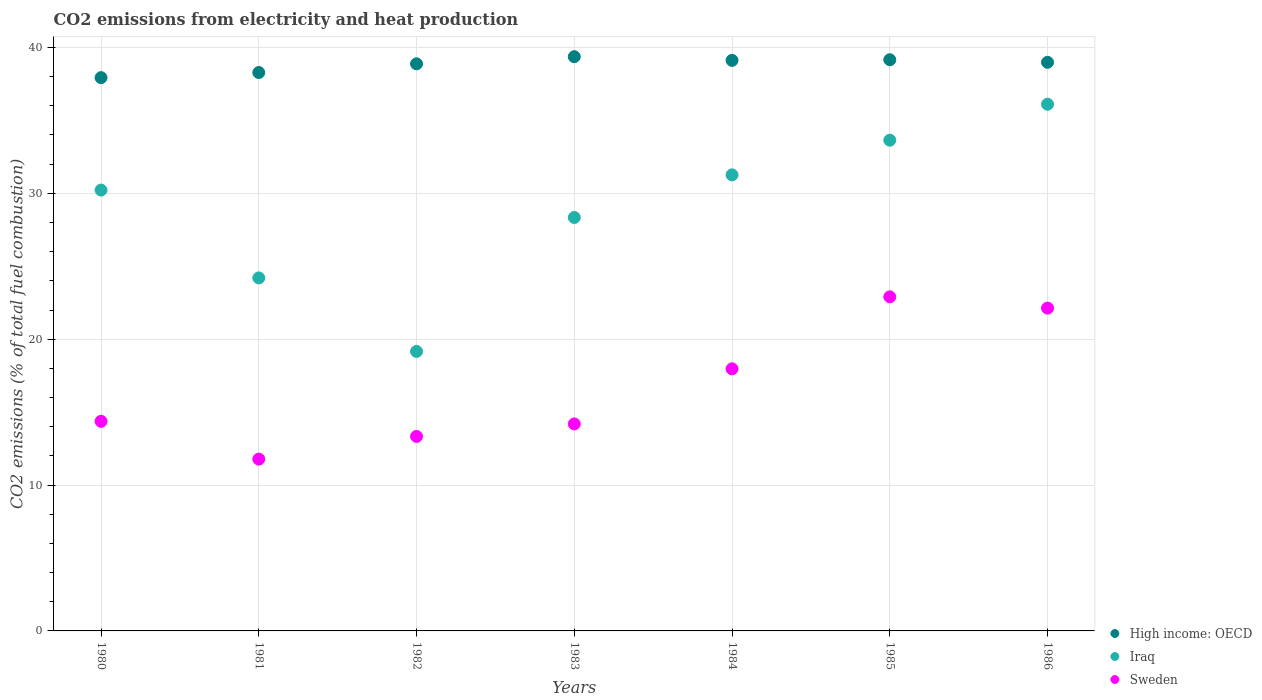Is the number of dotlines equal to the number of legend labels?
Make the answer very short. Yes. What is the amount of CO2 emitted in Sweden in 1981?
Provide a succinct answer. 11.78. Across all years, what is the maximum amount of CO2 emitted in Iraq?
Your answer should be compact. 36.11. Across all years, what is the minimum amount of CO2 emitted in High income: OECD?
Provide a short and direct response. 37.93. In which year was the amount of CO2 emitted in Sweden maximum?
Your answer should be very brief. 1985. In which year was the amount of CO2 emitted in Sweden minimum?
Your answer should be compact. 1981. What is the total amount of CO2 emitted in High income: OECD in the graph?
Offer a terse response. 271.71. What is the difference between the amount of CO2 emitted in High income: OECD in 1981 and that in 1986?
Provide a short and direct response. -0.7. What is the difference between the amount of CO2 emitted in High income: OECD in 1983 and the amount of CO2 emitted in Sweden in 1981?
Keep it short and to the point. 27.59. What is the average amount of CO2 emitted in High income: OECD per year?
Make the answer very short. 38.82. In the year 1985, what is the difference between the amount of CO2 emitted in Sweden and amount of CO2 emitted in High income: OECD?
Offer a terse response. -16.25. What is the ratio of the amount of CO2 emitted in Sweden in 1982 to that in 1985?
Provide a succinct answer. 0.58. Is the amount of CO2 emitted in Iraq in 1983 less than that in 1986?
Give a very brief answer. Yes. What is the difference between the highest and the second highest amount of CO2 emitted in High income: OECD?
Ensure brevity in your answer.  0.21. What is the difference between the highest and the lowest amount of CO2 emitted in Sweden?
Ensure brevity in your answer.  11.12. In how many years, is the amount of CO2 emitted in Iraq greater than the average amount of CO2 emitted in Iraq taken over all years?
Provide a short and direct response. 4. Is the sum of the amount of CO2 emitted in Sweden in 1980 and 1982 greater than the maximum amount of CO2 emitted in Iraq across all years?
Ensure brevity in your answer.  No. Is the amount of CO2 emitted in Iraq strictly greater than the amount of CO2 emitted in Sweden over the years?
Provide a short and direct response. Yes. Is the amount of CO2 emitted in High income: OECD strictly less than the amount of CO2 emitted in Iraq over the years?
Ensure brevity in your answer.  No. How many years are there in the graph?
Keep it short and to the point. 7. What is the title of the graph?
Keep it short and to the point. CO2 emissions from electricity and heat production. Does "Suriname" appear as one of the legend labels in the graph?
Keep it short and to the point. No. What is the label or title of the Y-axis?
Your answer should be very brief. CO2 emissions (% of total fuel combustion). What is the CO2 emissions (% of total fuel combustion) of High income: OECD in 1980?
Keep it short and to the point. 37.93. What is the CO2 emissions (% of total fuel combustion) in Iraq in 1980?
Your answer should be very brief. 30.22. What is the CO2 emissions (% of total fuel combustion) of Sweden in 1980?
Your response must be concise. 14.37. What is the CO2 emissions (% of total fuel combustion) in High income: OECD in 1981?
Make the answer very short. 38.28. What is the CO2 emissions (% of total fuel combustion) of Iraq in 1981?
Your response must be concise. 24.2. What is the CO2 emissions (% of total fuel combustion) in Sweden in 1981?
Make the answer very short. 11.78. What is the CO2 emissions (% of total fuel combustion) of High income: OECD in 1982?
Your response must be concise. 38.88. What is the CO2 emissions (% of total fuel combustion) in Iraq in 1982?
Your answer should be very brief. 19.16. What is the CO2 emissions (% of total fuel combustion) in Sweden in 1982?
Your answer should be compact. 13.33. What is the CO2 emissions (% of total fuel combustion) of High income: OECD in 1983?
Your answer should be compact. 39.37. What is the CO2 emissions (% of total fuel combustion) of Iraq in 1983?
Your answer should be compact. 28.34. What is the CO2 emissions (% of total fuel combustion) in Sweden in 1983?
Your answer should be compact. 14.19. What is the CO2 emissions (% of total fuel combustion) in High income: OECD in 1984?
Your answer should be very brief. 39.11. What is the CO2 emissions (% of total fuel combustion) in Iraq in 1984?
Provide a succinct answer. 31.26. What is the CO2 emissions (% of total fuel combustion) of Sweden in 1984?
Your response must be concise. 17.97. What is the CO2 emissions (% of total fuel combustion) of High income: OECD in 1985?
Your answer should be compact. 39.16. What is the CO2 emissions (% of total fuel combustion) of Iraq in 1985?
Give a very brief answer. 33.64. What is the CO2 emissions (% of total fuel combustion) in Sweden in 1985?
Offer a terse response. 22.9. What is the CO2 emissions (% of total fuel combustion) in High income: OECD in 1986?
Make the answer very short. 38.98. What is the CO2 emissions (% of total fuel combustion) of Iraq in 1986?
Offer a very short reply. 36.11. What is the CO2 emissions (% of total fuel combustion) of Sweden in 1986?
Offer a very short reply. 22.13. Across all years, what is the maximum CO2 emissions (% of total fuel combustion) of High income: OECD?
Give a very brief answer. 39.37. Across all years, what is the maximum CO2 emissions (% of total fuel combustion) in Iraq?
Offer a terse response. 36.11. Across all years, what is the maximum CO2 emissions (% of total fuel combustion) of Sweden?
Offer a very short reply. 22.9. Across all years, what is the minimum CO2 emissions (% of total fuel combustion) of High income: OECD?
Provide a short and direct response. 37.93. Across all years, what is the minimum CO2 emissions (% of total fuel combustion) in Iraq?
Your answer should be very brief. 19.16. Across all years, what is the minimum CO2 emissions (% of total fuel combustion) in Sweden?
Give a very brief answer. 11.78. What is the total CO2 emissions (% of total fuel combustion) in High income: OECD in the graph?
Keep it short and to the point. 271.71. What is the total CO2 emissions (% of total fuel combustion) in Iraq in the graph?
Give a very brief answer. 202.94. What is the total CO2 emissions (% of total fuel combustion) in Sweden in the graph?
Offer a terse response. 116.67. What is the difference between the CO2 emissions (% of total fuel combustion) in High income: OECD in 1980 and that in 1981?
Your answer should be compact. -0.35. What is the difference between the CO2 emissions (% of total fuel combustion) of Iraq in 1980 and that in 1981?
Your answer should be very brief. 6.02. What is the difference between the CO2 emissions (% of total fuel combustion) of Sweden in 1980 and that in 1981?
Offer a terse response. 2.59. What is the difference between the CO2 emissions (% of total fuel combustion) of High income: OECD in 1980 and that in 1982?
Provide a succinct answer. -0.95. What is the difference between the CO2 emissions (% of total fuel combustion) of Iraq in 1980 and that in 1982?
Offer a very short reply. 11.06. What is the difference between the CO2 emissions (% of total fuel combustion) in Sweden in 1980 and that in 1982?
Offer a very short reply. 1.03. What is the difference between the CO2 emissions (% of total fuel combustion) in High income: OECD in 1980 and that in 1983?
Offer a terse response. -1.44. What is the difference between the CO2 emissions (% of total fuel combustion) in Iraq in 1980 and that in 1983?
Provide a short and direct response. 1.88. What is the difference between the CO2 emissions (% of total fuel combustion) in Sweden in 1980 and that in 1983?
Offer a terse response. 0.18. What is the difference between the CO2 emissions (% of total fuel combustion) in High income: OECD in 1980 and that in 1984?
Ensure brevity in your answer.  -1.18. What is the difference between the CO2 emissions (% of total fuel combustion) in Iraq in 1980 and that in 1984?
Make the answer very short. -1.04. What is the difference between the CO2 emissions (% of total fuel combustion) in Sweden in 1980 and that in 1984?
Make the answer very short. -3.6. What is the difference between the CO2 emissions (% of total fuel combustion) of High income: OECD in 1980 and that in 1985?
Your response must be concise. -1.23. What is the difference between the CO2 emissions (% of total fuel combustion) in Iraq in 1980 and that in 1985?
Make the answer very short. -3.42. What is the difference between the CO2 emissions (% of total fuel combustion) of Sweden in 1980 and that in 1985?
Offer a terse response. -8.53. What is the difference between the CO2 emissions (% of total fuel combustion) in High income: OECD in 1980 and that in 1986?
Offer a terse response. -1.05. What is the difference between the CO2 emissions (% of total fuel combustion) of Iraq in 1980 and that in 1986?
Keep it short and to the point. -5.88. What is the difference between the CO2 emissions (% of total fuel combustion) of Sweden in 1980 and that in 1986?
Provide a succinct answer. -7.76. What is the difference between the CO2 emissions (% of total fuel combustion) of High income: OECD in 1981 and that in 1982?
Keep it short and to the point. -0.6. What is the difference between the CO2 emissions (% of total fuel combustion) of Iraq in 1981 and that in 1982?
Provide a short and direct response. 5.04. What is the difference between the CO2 emissions (% of total fuel combustion) of Sweden in 1981 and that in 1982?
Provide a short and direct response. -1.56. What is the difference between the CO2 emissions (% of total fuel combustion) in High income: OECD in 1981 and that in 1983?
Provide a succinct answer. -1.08. What is the difference between the CO2 emissions (% of total fuel combustion) in Iraq in 1981 and that in 1983?
Ensure brevity in your answer.  -4.14. What is the difference between the CO2 emissions (% of total fuel combustion) of Sweden in 1981 and that in 1983?
Give a very brief answer. -2.41. What is the difference between the CO2 emissions (% of total fuel combustion) of High income: OECD in 1981 and that in 1984?
Give a very brief answer. -0.83. What is the difference between the CO2 emissions (% of total fuel combustion) in Iraq in 1981 and that in 1984?
Provide a succinct answer. -7.06. What is the difference between the CO2 emissions (% of total fuel combustion) of Sweden in 1981 and that in 1984?
Ensure brevity in your answer.  -6.19. What is the difference between the CO2 emissions (% of total fuel combustion) of High income: OECD in 1981 and that in 1985?
Keep it short and to the point. -0.88. What is the difference between the CO2 emissions (% of total fuel combustion) of Iraq in 1981 and that in 1985?
Provide a short and direct response. -9.44. What is the difference between the CO2 emissions (% of total fuel combustion) in Sweden in 1981 and that in 1985?
Offer a terse response. -11.12. What is the difference between the CO2 emissions (% of total fuel combustion) in High income: OECD in 1981 and that in 1986?
Ensure brevity in your answer.  -0.7. What is the difference between the CO2 emissions (% of total fuel combustion) of Iraq in 1981 and that in 1986?
Offer a terse response. -11.91. What is the difference between the CO2 emissions (% of total fuel combustion) in Sweden in 1981 and that in 1986?
Provide a short and direct response. -10.35. What is the difference between the CO2 emissions (% of total fuel combustion) of High income: OECD in 1982 and that in 1983?
Your answer should be compact. -0.49. What is the difference between the CO2 emissions (% of total fuel combustion) of Iraq in 1982 and that in 1983?
Make the answer very short. -9.18. What is the difference between the CO2 emissions (% of total fuel combustion) of Sweden in 1982 and that in 1983?
Offer a terse response. -0.86. What is the difference between the CO2 emissions (% of total fuel combustion) in High income: OECD in 1982 and that in 1984?
Your answer should be compact. -0.24. What is the difference between the CO2 emissions (% of total fuel combustion) of Iraq in 1982 and that in 1984?
Keep it short and to the point. -12.1. What is the difference between the CO2 emissions (% of total fuel combustion) of Sweden in 1982 and that in 1984?
Offer a terse response. -4.63. What is the difference between the CO2 emissions (% of total fuel combustion) in High income: OECD in 1982 and that in 1985?
Offer a very short reply. -0.28. What is the difference between the CO2 emissions (% of total fuel combustion) in Iraq in 1982 and that in 1985?
Your response must be concise. -14.48. What is the difference between the CO2 emissions (% of total fuel combustion) in Sweden in 1982 and that in 1985?
Make the answer very short. -9.57. What is the difference between the CO2 emissions (% of total fuel combustion) of High income: OECD in 1982 and that in 1986?
Make the answer very short. -0.1. What is the difference between the CO2 emissions (% of total fuel combustion) in Iraq in 1982 and that in 1986?
Offer a terse response. -16.95. What is the difference between the CO2 emissions (% of total fuel combustion) of Sweden in 1982 and that in 1986?
Offer a very short reply. -8.8. What is the difference between the CO2 emissions (% of total fuel combustion) of High income: OECD in 1983 and that in 1984?
Make the answer very short. 0.25. What is the difference between the CO2 emissions (% of total fuel combustion) in Iraq in 1983 and that in 1984?
Your answer should be compact. -2.92. What is the difference between the CO2 emissions (% of total fuel combustion) of Sweden in 1983 and that in 1984?
Provide a short and direct response. -3.78. What is the difference between the CO2 emissions (% of total fuel combustion) of High income: OECD in 1983 and that in 1985?
Make the answer very short. 0.21. What is the difference between the CO2 emissions (% of total fuel combustion) in Iraq in 1983 and that in 1985?
Provide a succinct answer. -5.3. What is the difference between the CO2 emissions (% of total fuel combustion) of Sweden in 1983 and that in 1985?
Your response must be concise. -8.71. What is the difference between the CO2 emissions (% of total fuel combustion) of High income: OECD in 1983 and that in 1986?
Make the answer very short. 0.39. What is the difference between the CO2 emissions (% of total fuel combustion) in Iraq in 1983 and that in 1986?
Your response must be concise. -7.76. What is the difference between the CO2 emissions (% of total fuel combustion) in Sweden in 1983 and that in 1986?
Your answer should be compact. -7.94. What is the difference between the CO2 emissions (% of total fuel combustion) of High income: OECD in 1984 and that in 1985?
Provide a short and direct response. -0.04. What is the difference between the CO2 emissions (% of total fuel combustion) in Iraq in 1984 and that in 1985?
Ensure brevity in your answer.  -2.38. What is the difference between the CO2 emissions (% of total fuel combustion) of Sweden in 1984 and that in 1985?
Your answer should be compact. -4.94. What is the difference between the CO2 emissions (% of total fuel combustion) of High income: OECD in 1984 and that in 1986?
Your answer should be very brief. 0.13. What is the difference between the CO2 emissions (% of total fuel combustion) in Iraq in 1984 and that in 1986?
Keep it short and to the point. -4.84. What is the difference between the CO2 emissions (% of total fuel combustion) in Sweden in 1984 and that in 1986?
Give a very brief answer. -4.16. What is the difference between the CO2 emissions (% of total fuel combustion) in High income: OECD in 1985 and that in 1986?
Give a very brief answer. 0.18. What is the difference between the CO2 emissions (% of total fuel combustion) in Iraq in 1985 and that in 1986?
Make the answer very short. -2.47. What is the difference between the CO2 emissions (% of total fuel combustion) of Sweden in 1985 and that in 1986?
Keep it short and to the point. 0.77. What is the difference between the CO2 emissions (% of total fuel combustion) of High income: OECD in 1980 and the CO2 emissions (% of total fuel combustion) of Iraq in 1981?
Your response must be concise. 13.73. What is the difference between the CO2 emissions (% of total fuel combustion) of High income: OECD in 1980 and the CO2 emissions (% of total fuel combustion) of Sweden in 1981?
Your answer should be very brief. 26.15. What is the difference between the CO2 emissions (% of total fuel combustion) of Iraq in 1980 and the CO2 emissions (% of total fuel combustion) of Sweden in 1981?
Provide a short and direct response. 18.44. What is the difference between the CO2 emissions (% of total fuel combustion) in High income: OECD in 1980 and the CO2 emissions (% of total fuel combustion) in Iraq in 1982?
Provide a short and direct response. 18.77. What is the difference between the CO2 emissions (% of total fuel combustion) of High income: OECD in 1980 and the CO2 emissions (% of total fuel combustion) of Sweden in 1982?
Offer a terse response. 24.6. What is the difference between the CO2 emissions (% of total fuel combustion) in Iraq in 1980 and the CO2 emissions (% of total fuel combustion) in Sweden in 1982?
Provide a succinct answer. 16.89. What is the difference between the CO2 emissions (% of total fuel combustion) in High income: OECD in 1980 and the CO2 emissions (% of total fuel combustion) in Iraq in 1983?
Your answer should be compact. 9.59. What is the difference between the CO2 emissions (% of total fuel combustion) in High income: OECD in 1980 and the CO2 emissions (% of total fuel combustion) in Sweden in 1983?
Keep it short and to the point. 23.74. What is the difference between the CO2 emissions (% of total fuel combustion) in Iraq in 1980 and the CO2 emissions (% of total fuel combustion) in Sweden in 1983?
Keep it short and to the point. 16.03. What is the difference between the CO2 emissions (% of total fuel combustion) of High income: OECD in 1980 and the CO2 emissions (% of total fuel combustion) of Iraq in 1984?
Provide a short and direct response. 6.67. What is the difference between the CO2 emissions (% of total fuel combustion) of High income: OECD in 1980 and the CO2 emissions (% of total fuel combustion) of Sweden in 1984?
Provide a short and direct response. 19.96. What is the difference between the CO2 emissions (% of total fuel combustion) in Iraq in 1980 and the CO2 emissions (% of total fuel combustion) in Sweden in 1984?
Provide a short and direct response. 12.25. What is the difference between the CO2 emissions (% of total fuel combustion) of High income: OECD in 1980 and the CO2 emissions (% of total fuel combustion) of Iraq in 1985?
Give a very brief answer. 4.29. What is the difference between the CO2 emissions (% of total fuel combustion) in High income: OECD in 1980 and the CO2 emissions (% of total fuel combustion) in Sweden in 1985?
Ensure brevity in your answer.  15.03. What is the difference between the CO2 emissions (% of total fuel combustion) in Iraq in 1980 and the CO2 emissions (% of total fuel combustion) in Sweden in 1985?
Your answer should be compact. 7.32. What is the difference between the CO2 emissions (% of total fuel combustion) of High income: OECD in 1980 and the CO2 emissions (% of total fuel combustion) of Iraq in 1986?
Your answer should be very brief. 1.82. What is the difference between the CO2 emissions (% of total fuel combustion) in High income: OECD in 1980 and the CO2 emissions (% of total fuel combustion) in Sweden in 1986?
Offer a terse response. 15.8. What is the difference between the CO2 emissions (% of total fuel combustion) in Iraq in 1980 and the CO2 emissions (% of total fuel combustion) in Sweden in 1986?
Your answer should be very brief. 8.09. What is the difference between the CO2 emissions (% of total fuel combustion) of High income: OECD in 1981 and the CO2 emissions (% of total fuel combustion) of Iraq in 1982?
Offer a terse response. 19.12. What is the difference between the CO2 emissions (% of total fuel combustion) in High income: OECD in 1981 and the CO2 emissions (% of total fuel combustion) in Sweden in 1982?
Provide a short and direct response. 24.95. What is the difference between the CO2 emissions (% of total fuel combustion) in Iraq in 1981 and the CO2 emissions (% of total fuel combustion) in Sweden in 1982?
Provide a short and direct response. 10.87. What is the difference between the CO2 emissions (% of total fuel combustion) of High income: OECD in 1981 and the CO2 emissions (% of total fuel combustion) of Iraq in 1983?
Offer a very short reply. 9.94. What is the difference between the CO2 emissions (% of total fuel combustion) of High income: OECD in 1981 and the CO2 emissions (% of total fuel combustion) of Sweden in 1983?
Your answer should be very brief. 24.09. What is the difference between the CO2 emissions (% of total fuel combustion) of Iraq in 1981 and the CO2 emissions (% of total fuel combustion) of Sweden in 1983?
Your answer should be compact. 10.01. What is the difference between the CO2 emissions (% of total fuel combustion) of High income: OECD in 1981 and the CO2 emissions (% of total fuel combustion) of Iraq in 1984?
Ensure brevity in your answer.  7.02. What is the difference between the CO2 emissions (% of total fuel combustion) in High income: OECD in 1981 and the CO2 emissions (% of total fuel combustion) in Sweden in 1984?
Give a very brief answer. 20.31. What is the difference between the CO2 emissions (% of total fuel combustion) in Iraq in 1981 and the CO2 emissions (% of total fuel combustion) in Sweden in 1984?
Give a very brief answer. 6.23. What is the difference between the CO2 emissions (% of total fuel combustion) in High income: OECD in 1981 and the CO2 emissions (% of total fuel combustion) in Iraq in 1985?
Your response must be concise. 4.64. What is the difference between the CO2 emissions (% of total fuel combustion) of High income: OECD in 1981 and the CO2 emissions (% of total fuel combustion) of Sweden in 1985?
Your answer should be very brief. 15.38. What is the difference between the CO2 emissions (% of total fuel combustion) in Iraq in 1981 and the CO2 emissions (% of total fuel combustion) in Sweden in 1985?
Ensure brevity in your answer.  1.3. What is the difference between the CO2 emissions (% of total fuel combustion) in High income: OECD in 1981 and the CO2 emissions (% of total fuel combustion) in Iraq in 1986?
Ensure brevity in your answer.  2.17. What is the difference between the CO2 emissions (% of total fuel combustion) in High income: OECD in 1981 and the CO2 emissions (% of total fuel combustion) in Sweden in 1986?
Ensure brevity in your answer.  16.15. What is the difference between the CO2 emissions (% of total fuel combustion) in Iraq in 1981 and the CO2 emissions (% of total fuel combustion) in Sweden in 1986?
Provide a succinct answer. 2.07. What is the difference between the CO2 emissions (% of total fuel combustion) in High income: OECD in 1982 and the CO2 emissions (% of total fuel combustion) in Iraq in 1983?
Give a very brief answer. 10.53. What is the difference between the CO2 emissions (% of total fuel combustion) of High income: OECD in 1982 and the CO2 emissions (% of total fuel combustion) of Sweden in 1983?
Provide a succinct answer. 24.69. What is the difference between the CO2 emissions (% of total fuel combustion) of Iraq in 1982 and the CO2 emissions (% of total fuel combustion) of Sweden in 1983?
Your answer should be very brief. 4.97. What is the difference between the CO2 emissions (% of total fuel combustion) in High income: OECD in 1982 and the CO2 emissions (% of total fuel combustion) in Iraq in 1984?
Provide a succinct answer. 7.61. What is the difference between the CO2 emissions (% of total fuel combustion) of High income: OECD in 1982 and the CO2 emissions (% of total fuel combustion) of Sweden in 1984?
Your answer should be very brief. 20.91. What is the difference between the CO2 emissions (% of total fuel combustion) of Iraq in 1982 and the CO2 emissions (% of total fuel combustion) of Sweden in 1984?
Your answer should be very brief. 1.19. What is the difference between the CO2 emissions (% of total fuel combustion) of High income: OECD in 1982 and the CO2 emissions (% of total fuel combustion) of Iraq in 1985?
Ensure brevity in your answer.  5.24. What is the difference between the CO2 emissions (% of total fuel combustion) of High income: OECD in 1982 and the CO2 emissions (% of total fuel combustion) of Sweden in 1985?
Your response must be concise. 15.97. What is the difference between the CO2 emissions (% of total fuel combustion) of Iraq in 1982 and the CO2 emissions (% of total fuel combustion) of Sweden in 1985?
Give a very brief answer. -3.74. What is the difference between the CO2 emissions (% of total fuel combustion) in High income: OECD in 1982 and the CO2 emissions (% of total fuel combustion) in Iraq in 1986?
Keep it short and to the point. 2.77. What is the difference between the CO2 emissions (% of total fuel combustion) in High income: OECD in 1982 and the CO2 emissions (% of total fuel combustion) in Sweden in 1986?
Provide a succinct answer. 16.75. What is the difference between the CO2 emissions (% of total fuel combustion) in Iraq in 1982 and the CO2 emissions (% of total fuel combustion) in Sweden in 1986?
Your answer should be very brief. -2.97. What is the difference between the CO2 emissions (% of total fuel combustion) of High income: OECD in 1983 and the CO2 emissions (% of total fuel combustion) of Iraq in 1984?
Make the answer very short. 8.1. What is the difference between the CO2 emissions (% of total fuel combustion) in High income: OECD in 1983 and the CO2 emissions (% of total fuel combustion) in Sweden in 1984?
Offer a terse response. 21.4. What is the difference between the CO2 emissions (% of total fuel combustion) of Iraq in 1983 and the CO2 emissions (% of total fuel combustion) of Sweden in 1984?
Offer a very short reply. 10.38. What is the difference between the CO2 emissions (% of total fuel combustion) in High income: OECD in 1983 and the CO2 emissions (% of total fuel combustion) in Iraq in 1985?
Your answer should be very brief. 5.72. What is the difference between the CO2 emissions (% of total fuel combustion) of High income: OECD in 1983 and the CO2 emissions (% of total fuel combustion) of Sweden in 1985?
Give a very brief answer. 16.46. What is the difference between the CO2 emissions (% of total fuel combustion) in Iraq in 1983 and the CO2 emissions (% of total fuel combustion) in Sweden in 1985?
Offer a terse response. 5.44. What is the difference between the CO2 emissions (% of total fuel combustion) of High income: OECD in 1983 and the CO2 emissions (% of total fuel combustion) of Iraq in 1986?
Your response must be concise. 3.26. What is the difference between the CO2 emissions (% of total fuel combustion) of High income: OECD in 1983 and the CO2 emissions (% of total fuel combustion) of Sweden in 1986?
Make the answer very short. 17.24. What is the difference between the CO2 emissions (% of total fuel combustion) in Iraq in 1983 and the CO2 emissions (% of total fuel combustion) in Sweden in 1986?
Give a very brief answer. 6.21. What is the difference between the CO2 emissions (% of total fuel combustion) of High income: OECD in 1984 and the CO2 emissions (% of total fuel combustion) of Iraq in 1985?
Offer a very short reply. 5.47. What is the difference between the CO2 emissions (% of total fuel combustion) in High income: OECD in 1984 and the CO2 emissions (% of total fuel combustion) in Sweden in 1985?
Your response must be concise. 16.21. What is the difference between the CO2 emissions (% of total fuel combustion) in Iraq in 1984 and the CO2 emissions (% of total fuel combustion) in Sweden in 1985?
Your answer should be compact. 8.36. What is the difference between the CO2 emissions (% of total fuel combustion) of High income: OECD in 1984 and the CO2 emissions (% of total fuel combustion) of Iraq in 1986?
Ensure brevity in your answer.  3.01. What is the difference between the CO2 emissions (% of total fuel combustion) in High income: OECD in 1984 and the CO2 emissions (% of total fuel combustion) in Sweden in 1986?
Your response must be concise. 16.98. What is the difference between the CO2 emissions (% of total fuel combustion) of Iraq in 1984 and the CO2 emissions (% of total fuel combustion) of Sweden in 1986?
Offer a terse response. 9.13. What is the difference between the CO2 emissions (% of total fuel combustion) of High income: OECD in 1985 and the CO2 emissions (% of total fuel combustion) of Iraq in 1986?
Offer a very short reply. 3.05. What is the difference between the CO2 emissions (% of total fuel combustion) in High income: OECD in 1985 and the CO2 emissions (% of total fuel combustion) in Sweden in 1986?
Offer a terse response. 17.03. What is the difference between the CO2 emissions (% of total fuel combustion) of Iraq in 1985 and the CO2 emissions (% of total fuel combustion) of Sweden in 1986?
Provide a short and direct response. 11.51. What is the average CO2 emissions (% of total fuel combustion) in High income: OECD per year?
Provide a short and direct response. 38.82. What is the average CO2 emissions (% of total fuel combustion) in Iraq per year?
Offer a very short reply. 28.99. What is the average CO2 emissions (% of total fuel combustion) in Sweden per year?
Provide a succinct answer. 16.67. In the year 1980, what is the difference between the CO2 emissions (% of total fuel combustion) in High income: OECD and CO2 emissions (% of total fuel combustion) in Iraq?
Your response must be concise. 7.71. In the year 1980, what is the difference between the CO2 emissions (% of total fuel combustion) in High income: OECD and CO2 emissions (% of total fuel combustion) in Sweden?
Your answer should be very brief. 23.56. In the year 1980, what is the difference between the CO2 emissions (% of total fuel combustion) of Iraq and CO2 emissions (% of total fuel combustion) of Sweden?
Offer a very short reply. 15.85. In the year 1981, what is the difference between the CO2 emissions (% of total fuel combustion) in High income: OECD and CO2 emissions (% of total fuel combustion) in Iraq?
Provide a short and direct response. 14.08. In the year 1981, what is the difference between the CO2 emissions (% of total fuel combustion) of High income: OECD and CO2 emissions (% of total fuel combustion) of Sweden?
Ensure brevity in your answer.  26.5. In the year 1981, what is the difference between the CO2 emissions (% of total fuel combustion) of Iraq and CO2 emissions (% of total fuel combustion) of Sweden?
Your answer should be very brief. 12.42. In the year 1982, what is the difference between the CO2 emissions (% of total fuel combustion) in High income: OECD and CO2 emissions (% of total fuel combustion) in Iraq?
Ensure brevity in your answer.  19.72. In the year 1982, what is the difference between the CO2 emissions (% of total fuel combustion) in High income: OECD and CO2 emissions (% of total fuel combustion) in Sweden?
Give a very brief answer. 25.54. In the year 1982, what is the difference between the CO2 emissions (% of total fuel combustion) of Iraq and CO2 emissions (% of total fuel combustion) of Sweden?
Offer a terse response. 5.83. In the year 1983, what is the difference between the CO2 emissions (% of total fuel combustion) in High income: OECD and CO2 emissions (% of total fuel combustion) in Iraq?
Give a very brief answer. 11.02. In the year 1983, what is the difference between the CO2 emissions (% of total fuel combustion) in High income: OECD and CO2 emissions (% of total fuel combustion) in Sweden?
Give a very brief answer. 25.18. In the year 1983, what is the difference between the CO2 emissions (% of total fuel combustion) of Iraq and CO2 emissions (% of total fuel combustion) of Sweden?
Give a very brief answer. 14.15. In the year 1984, what is the difference between the CO2 emissions (% of total fuel combustion) in High income: OECD and CO2 emissions (% of total fuel combustion) in Iraq?
Your answer should be compact. 7.85. In the year 1984, what is the difference between the CO2 emissions (% of total fuel combustion) of High income: OECD and CO2 emissions (% of total fuel combustion) of Sweden?
Your answer should be compact. 21.15. In the year 1984, what is the difference between the CO2 emissions (% of total fuel combustion) of Iraq and CO2 emissions (% of total fuel combustion) of Sweden?
Give a very brief answer. 13.3. In the year 1985, what is the difference between the CO2 emissions (% of total fuel combustion) of High income: OECD and CO2 emissions (% of total fuel combustion) of Iraq?
Ensure brevity in your answer.  5.52. In the year 1985, what is the difference between the CO2 emissions (% of total fuel combustion) of High income: OECD and CO2 emissions (% of total fuel combustion) of Sweden?
Your answer should be compact. 16.25. In the year 1985, what is the difference between the CO2 emissions (% of total fuel combustion) in Iraq and CO2 emissions (% of total fuel combustion) in Sweden?
Your answer should be very brief. 10.74. In the year 1986, what is the difference between the CO2 emissions (% of total fuel combustion) in High income: OECD and CO2 emissions (% of total fuel combustion) in Iraq?
Provide a succinct answer. 2.87. In the year 1986, what is the difference between the CO2 emissions (% of total fuel combustion) in High income: OECD and CO2 emissions (% of total fuel combustion) in Sweden?
Provide a succinct answer. 16.85. In the year 1986, what is the difference between the CO2 emissions (% of total fuel combustion) of Iraq and CO2 emissions (% of total fuel combustion) of Sweden?
Ensure brevity in your answer.  13.98. What is the ratio of the CO2 emissions (% of total fuel combustion) in Iraq in 1980 to that in 1981?
Offer a terse response. 1.25. What is the ratio of the CO2 emissions (% of total fuel combustion) of Sweden in 1980 to that in 1981?
Your response must be concise. 1.22. What is the ratio of the CO2 emissions (% of total fuel combustion) in High income: OECD in 1980 to that in 1982?
Provide a short and direct response. 0.98. What is the ratio of the CO2 emissions (% of total fuel combustion) in Iraq in 1980 to that in 1982?
Keep it short and to the point. 1.58. What is the ratio of the CO2 emissions (% of total fuel combustion) of Sweden in 1980 to that in 1982?
Make the answer very short. 1.08. What is the ratio of the CO2 emissions (% of total fuel combustion) in High income: OECD in 1980 to that in 1983?
Your answer should be compact. 0.96. What is the ratio of the CO2 emissions (% of total fuel combustion) in Iraq in 1980 to that in 1983?
Your answer should be compact. 1.07. What is the ratio of the CO2 emissions (% of total fuel combustion) of Sweden in 1980 to that in 1983?
Your answer should be very brief. 1.01. What is the ratio of the CO2 emissions (% of total fuel combustion) in High income: OECD in 1980 to that in 1984?
Offer a very short reply. 0.97. What is the ratio of the CO2 emissions (% of total fuel combustion) in Iraq in 1980 to that in 1984?
Your answer should be compact. 0.97. What is the ratio of the CO2 emissions (% of total fuel combustion) in Sweden in 1980 to that in 1984?
Your response must be concise. 0.8. What is the ratio of the CO2 emissions (% of total fuel combustion) in High income: OECD in 1980 to that in 1985?
Provide a short and direct response. 0.97. What is the ratio of the CO2 emissions (% of total fuel combustion) of Iraq in 1980 to that in 1985?
Provide a short and direct response. 0.9. What is the ratio of the CO2 emissions (% of total fuel combustion) of Sweden in 1980 to that in 1985?
Offer a very short reply. 0.63. What is the ratio of the CO2 emissions (% of total fuel combustion) in High income: OECD in 1980 to that in 1986?
Your answer should be compact. 0.97. What is the ratio of the CO2 emissions (% of total fuel combustion) of Iraq in 1980 to that in 1986?
Keep it short and to the point. 0.84. What is the ratio of the CO2 emissions (% of total fuel combustion) in Sweden in 1980 to that in 1986?
Give a very brief answer. 0.65. What is the ratio of the CO2 emissions (% of total fuel combustion) in High income: OECD in 1981 to that in 1982?
Your response must be concise. 0.98. What is the ratio of the CO2 emissions (% of total fuel combustion) of Iraq in 1981 to that in 1982?
Your response must be concise. 1.26. What is the ratio of the CO2 emissions (% of total fuel combustion) in Sweden in 1981 to that in 1982?
Your response must be concise. 0.88. What is the ratio of the CO2 emissions (% of total fuel combustion) of High income: OECD in 1981 to that in 1983?
Your answer should be compact. 0.97. What is the ratio of the CO2 emissions (% of total fuel combustion) in Iraq in 1981 to that in 1983?
Give a very brief answer. 0.85. What is the ratio of the CO2 emissions (% of total fuel combustion) of Sweden in 1981 to that in 1983?
Your answer should be very brief. 0.83. What is the ratio of the CO2 emissions (% of total fuel combustion) of High income: OECD in 1981 to that in 1984?
Make the answer very short. 0.98. What is the ratio of the CO2 emissions (% of total fuel combustion) in Iraq in 1981 to that in 1984?
Provide a succinct answer. 0.77. What is the ratio of the CO2 emissions (% of total fuel combustion) in Sweden in 1981 to that in 1984?
Give a very brief answer. 0.66. What is the ratio of the CO2 emissions (% of total fuel combustion) in High income: OECD in 1981 to that in 1985?
Your answer should be compact. 0.98. What is the ratio of the CO2 emissions (% of total fuel combustion) in Iraq in 1981 to that in 1985?
Keep it short and to the point. 0.72. What is the ratio of the CO2 emissions (% of total fuel combustion) in Sweden in 1981 to that in 1985?
Ensure brevity in your answer.  0.51. What is the ratio of the CO2 emissions (% of total fuel combustion) in High income: OECD in 1981 to that in 1986?
Your response must be concise. 0.98. What is the ratio of the CO2 emissions (% of total fuel combustion) of Iraq in 1981 to that in 1986?
Your answer should be very brief. 0.67. What is the ratio of the CO2 emissions (% of total fuel combustion) of Sweden in 1981 to that in 1986?
Your response must be concise. 0.53. What is the ratio of the CO2 emissions (% of total fuel combustion) of High income: OECD in 1982 to that in 1983?
Your answer should be compact. 0.99. What is the ratio of the CO2 emissions (% of total fuel combustion) in Iraq in 1982 to that in 1983?
Offer a very short reply. 0.68. What is the ratio of the CO2 emissions (% of total fuel combustion) of Sweden in 1982 to that in 1983?
Keep it short and to the point. 0.94. What is the ratio of the CO2 emissions (% of total fuel combustion) of High income: OECD in 1982 to that in 1984?
Give a very brief answer. 0.99. What is the ratio of the CO2 emissions (% of total fuel combustion) of Iraq in 1982 to that in 1984?
Your answer should be very brief. 0.61. What is the ratio of the CO2 emissions (% of total fuel combustion) of Sweden in 1982 to that in 1984?
Ensure brevity in your answer.  0.74. What is the ratio of the CO2 emissions (% of total fuel combustion) in Iraq in 1982 to that in 1985?
Offer a terse response. 0.57. What is the ratio of the CO2 emissions (% of total fuel combustion) in Sweden in 1982 to that in 1985?
Ensure brevity in your answer.  0.58. What is the ratio of the CO2 emissions (% of total fuel combustion) of High income: OECD in 1982 to that in 1986?
Give a very brief answer. 1. What is the ratio of the CO2 emissions (% of total fuel combustion) in Iraq in 1982 to that in 1986?
Give a very brief answer. 0.53. What is the ratio of the CO2 emissions (% of total fuel combustion) in Sweden in 1982 to that in 1986?
Make the answer very short. 0.6. What is the ratio of the CO2 emissions (% of total fuel combustion) in Iraq in 1983 to that in 1984?
Provide a short and direct response. 0.91. What is the ratio of the CO2 emissions (% of total fuel combustion) of Sweden in 1983 to that in 1984?
Your answer should be compact. 0.79. What is the ratio of the CO2 emissions (% of total fuel combustion) of High income: OECD in 1983 to that in 1985?
Your response must be concise. 1.01. What is the ratio of the CO2 emissions (% of total fuel combustion) of Iraq in 1983 to that in 1985?
Provide a short and direct response. 0.84. What is the ratio of the CO2 emissions (% of total fuel combustion) in Sweden in 1983 to that in 1985?
Ensure brevity in your answer.  0.62. What is the ratio of the CO2 emissions (% of total fuel combustion) in High income: OECD in 1983 to that in 1986?
Make the answer very short. 1.01. What is the ratio of the CO2 emissions (% of total fuel combustion) in Iraq in 1983 to that in 1986?
Keep it short and to the point. 0.79. What is the ratio of the CO2 emissions (% of total fuel combustion) in Sweden in 1983 to that in 1986?
Make the answer very short. 0.64. What is the ratio of the CO2 emissions (% of total fuel combustion) of Iraq in 1984 to that in 1985?
Ensure brevity in your answer.  0.93. What is the ratio of the CO2 emissions (% of total fuel combustion) of Sweden in 1984 to that in 1985?
Provide a short and direct response. 0.78. What is the ratio of the CO2 emissions (% of total fuel combustion) in Iraq in 1984 to that in 1986?
Make the answer very short. 0.87. What is the ratio of the CO2 emissions (% of total fuel combustion) in Sweden in 1984 to that in 1986?
Keep it short and to the point. 0.81. What is the ratio of the CO2 emissions (% of total fuel combustion) of Iraq in 1985 to that in 1986?
Provide a succinct answer. 0.93. What is the ratio of the CO2 emissions (% of total fuel combustion) in Sweden in 1985 to that in 1986?
Ensure brevity in your answer.  1.03. What is the difference between the highest and the second highest CO2 emissions (% of total fuel combustion) of High income: OECD?
Provide a succinct answer. 0.21. What is the difference between the highest and the second highest CO2 emissions (% of total fuel combustion) of Iraq?
Your response must be concise. 2.47. What is the difference between the highest and the second highest CO2 emissions (% of total fuel combustion) of Sweden?
Offer a terse response. 0.77. What is the difference between the highest and the lowest CO2 emissions (% of total fuel combustion) in High income: OECD?
Provide a short and direct response. 1.44. What is the difference between the highest and the lowest CO2 emissions (% of total fuel combustion) in Iraq?
Give a very brief answer. 16.95. What is the difference between the highest and the lowest CO2 emissions (% of total fuel combustion) in Sweden?
Your answer should be very brief. 11.12. 